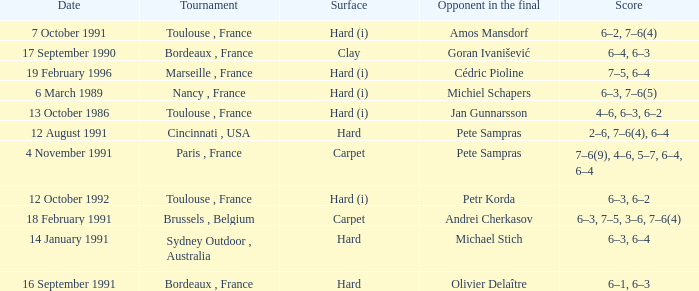What is the date of the tournament with olivier delaître as the opponent in the final? 16 September 1991. 